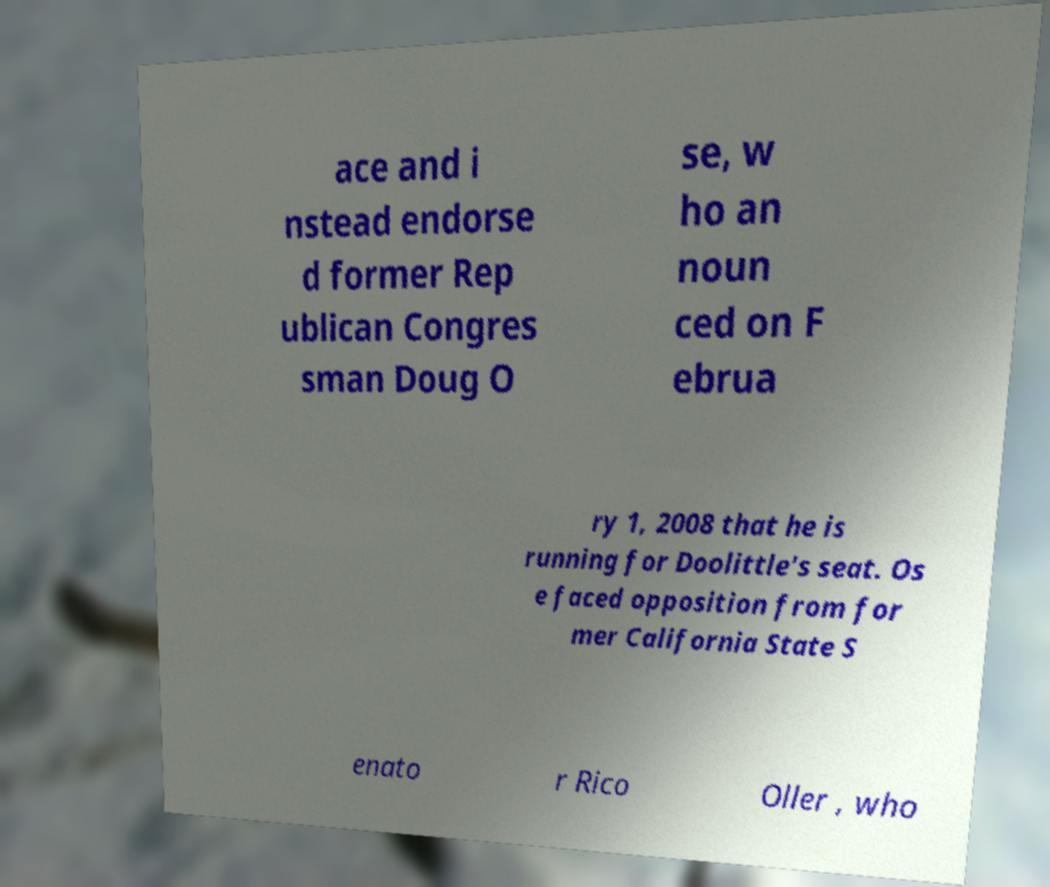Can you accurately transcribe the text from the provided image for me? ace and i nstead endorse d former Rep ublican Congres sman Doug O se, w ho an noun ced on F ebrua ry 1, 2008 that he is running for Doolittle's seat. Os e faced opposition from for mer California State S enato r Rico Oller , who 